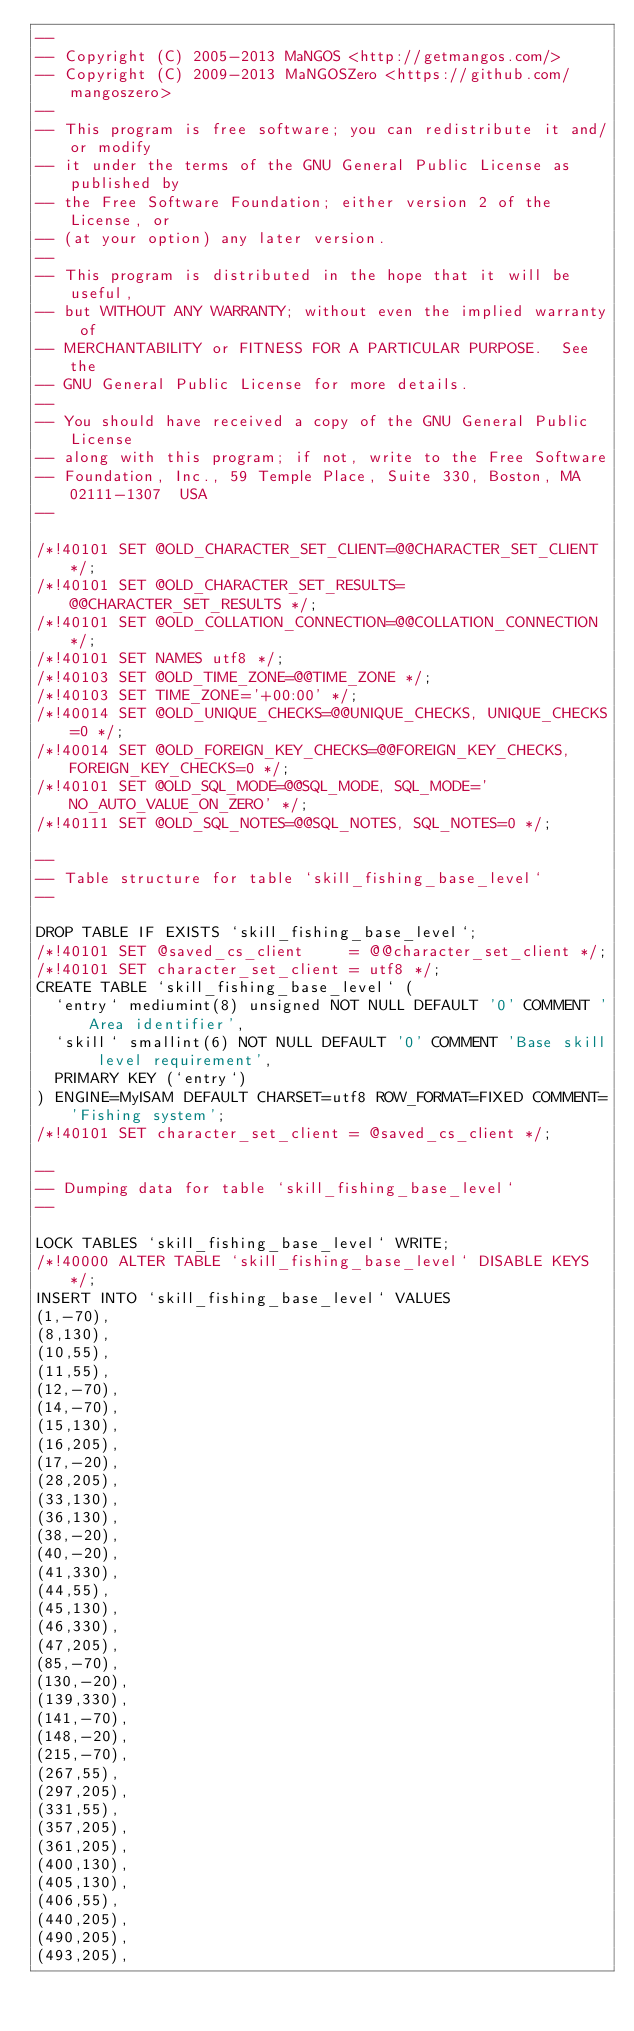Convert code to text. <code><loc_0><loc_0><loc_500><loc_500><_SQL_>--
-- Copyright (C) 2005-2013 MaNGOS <http://getmangos.com/>
-- Copyright (C) 2009-2013 MaNGOSZero <https://github.com/mangoszero>
--
-- This program is free software; you can redistribute it and/or modify
-- it under the terms of the GNU General Public License as published by
-- the Free Software Foundation; either version 2 of the License, or
-- (at your option) any later version.
--
-- This program is distributed in the hope that it will be useful,
-- but WITHOUT ANY WARRANTY; without even the implied warranty of
-- MERCHANTABILITY or FITNESS FOR A PARTICULAR PURPOSE.  See the
-- GNU General Public License for more details.
--
-- You should have received a copy of the GNU General Public License
-- along with this program; if not, write to the Free Software
-- Foundation, Inc., 59 Temple Place, Suite 330, Boston, MA  02111-1307  USA
--

/*!40101 SET @OLD_CHARACTER_SET_CLIENT=@@CHARACTER_SET_CLIENT */;
/*!40101 SET @OLD_CHARACTER_SET_RESULTS=@@CHARACTER_SET_RESULTS */;
/*!40101 SET @OLD_COLLATION_CONNECTION=@@COLLATION_CONNECTION */;
/*!40101 SET NAMES utf8 */;
/*!40103 SET @OLD_TIME_ZONE=@@TIME_ZONE */;
/*!40103 SET TIME_ZONE='+00:00' */;
/*!40014 SET @OLD_UNIQUE_CHECKS=@@UNIQUE_CHECKS, UNIQUE_CHECKS=0 */;
/*!40014 SET @OLD_FOREIGN_KEY_CHECKS=@@FOREIGN_KEY_CHECKS, FOREIGN_KEY_CHECKS=0 */;
/*!40101 SET @OLD_SQL_MODE=@@SQL_MODE, SQL_MODE='NO_AUTO_VALUE_ON_ZERO' */;
/*!40111 SET @OLD_SQL_NOTES=@@SQL_NOTES, SQL_NOTES=0 */;

--
-- Table structure for table `skill_fishing_base_level`
--

DROP TABLE IF EXISTS `skill_fishing_base_level`;
/*!40101 SET @saved_cs_client     = @@character_set_client */;
/*!40101 SET character_set_client = utf8 */;
CREATE TABLE `skill_fishing_base_level` (
  `entry` mediumint(8) unsigned NOT NULL DEFAULT '0' COMMENT 'Area identifier',
  `skill` smallint(6) NOT NULL DEFAULT '0' COMMENT 'Base skill level requirement',
  PRIMARY KEY (`entry`)
) ENGINE=MyISAM DEFAULT CHARSET=utf8 ROW_FORMAT=FIXED COMMENT='Fishing system';
/*!40101 SET character_set_client = @saved_cs_client */;

--
-- Dumping data for table `skill_fishing_base_level`
--

LOCK TABLES `skill_fishing_base_level` WRITE;
/*!40000 ALTER TABLE `skill_fishing_base_level` DISABLE KEYS */;
INSERT INTO `skill_fishing_base_level` VALUES
(1,-70),
(8,130),
(10,55),
(11,55),
(12,-70),
(14,-70),
(15,130),
(16,205),
(17,-20),
(28,205),
(33,130),
(36,130),
(38,-20),
(40,-20),
(41,330),
(44,55),
(45,130),
(46,330),
(47,205),
(85,-70),
(130,-20),
(139,330),
(141,-70),
(148,-20),
(215,-70),
(267,55),
(297,205),
(331,55),
(357,205),
(361,205),
(400,130),
(405,130),
(406,55),
(440,205),
(490,205),
(493,205),</code> 